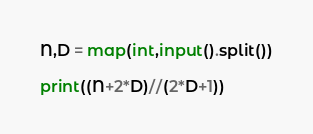<code> <loc_0><loc_0><loc_500><loc_500><_Python_>N,D = map(int,input().split())

print((N+2*D)//(2*D+1))</code> 